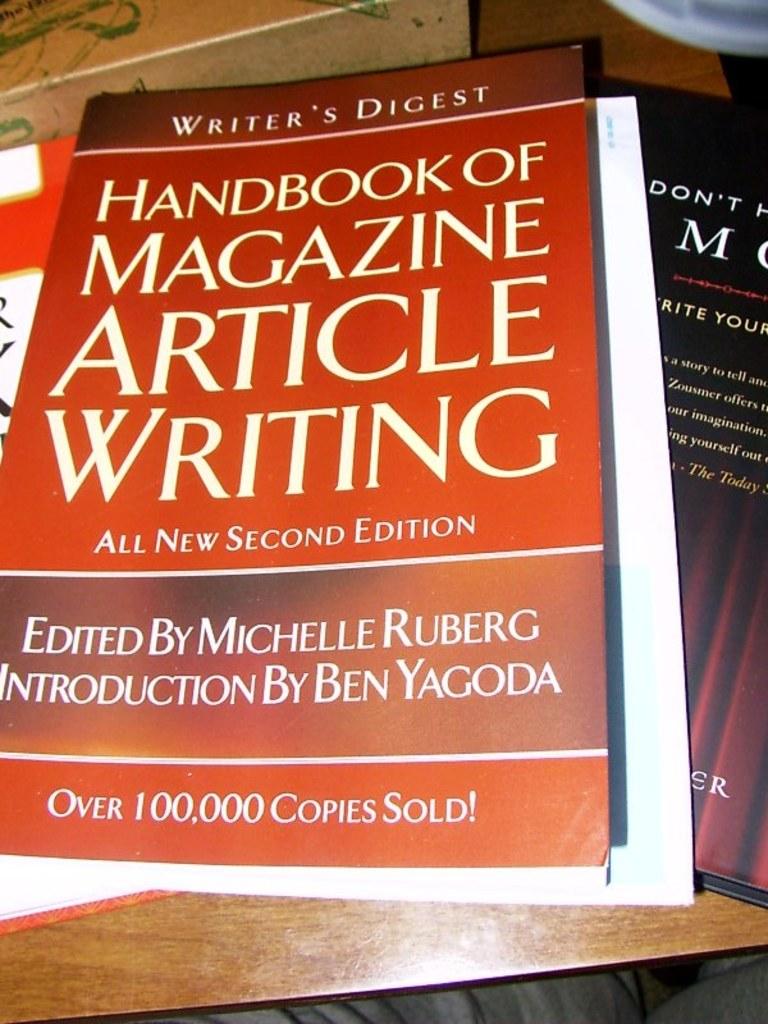What is the books title?
Offer a terse response. Handbook of magazine article writing. 